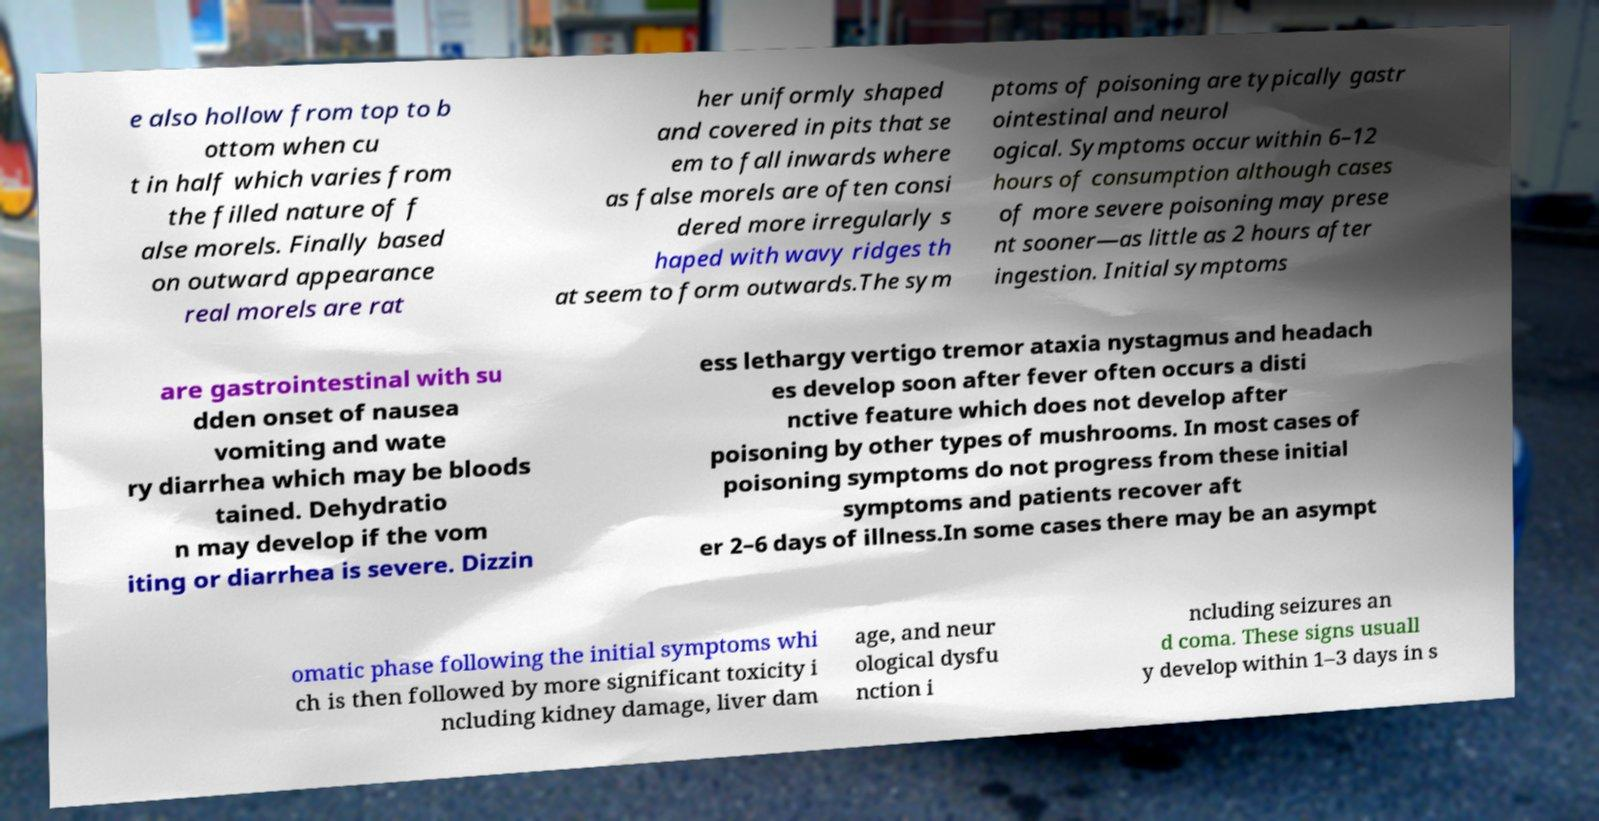Please identify and transcribe the text found in this image. e also hollow from top to b ottom when cu t in half which varies from the filled nature of f alse morels. Finally based on outward appearance real morels are rat her uniformly shaped and covered in pits that se em to fall inwards where as false morels are often consi dered more irregularly s haped with wavy ridges th at seem to form outwards.The sym ptoms of poisoning are typically gastr ointestinal and neurol ogical. Symptoms occur within 6–12 hours of consumption although cases of more severe poisoning may prese nt sooner—as little as 2 hours after ingestion. Initial symptoms are gastrointestinal with su dden onset of nausea vomiting and wate ry diarrhea which may be bloods tained. Dehydratio n may develop if the vom iting or diarrhea is severe. Dizzin ess lethargy vertigo tremor ataxia nystagmus and headach es develop soon after fever often occurs a disti nctive feature which does not develop after poisoning by other types of mushrooms. In most cases of poisoning symptoms do not progress from these initial symptoms and patients recover aft er 2–6 days of illness.In some cases there may be an asympt omatic phase following the initial symptoms whi ch is then followed by more significant toxicity i ncluding kidney damage, liver dam age, and neur ological dysfu nction i ncluding seizures an d coma. These signs usuall y develop within 1–3 days in s 